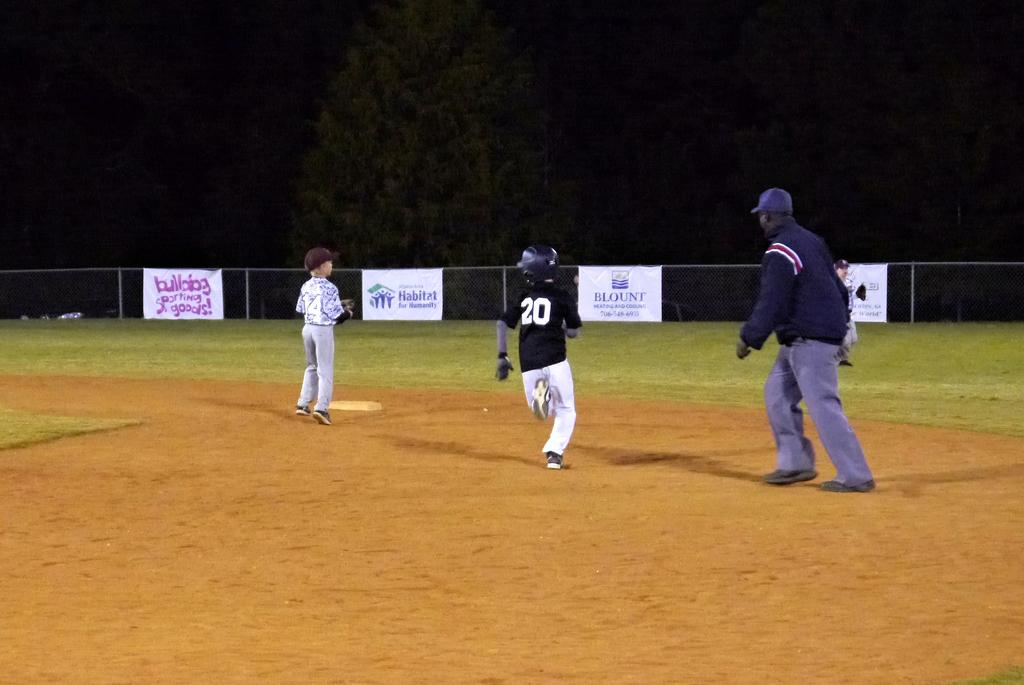<image>
Present a compact description of the photo's key features. a player with the number 20 running around bases 